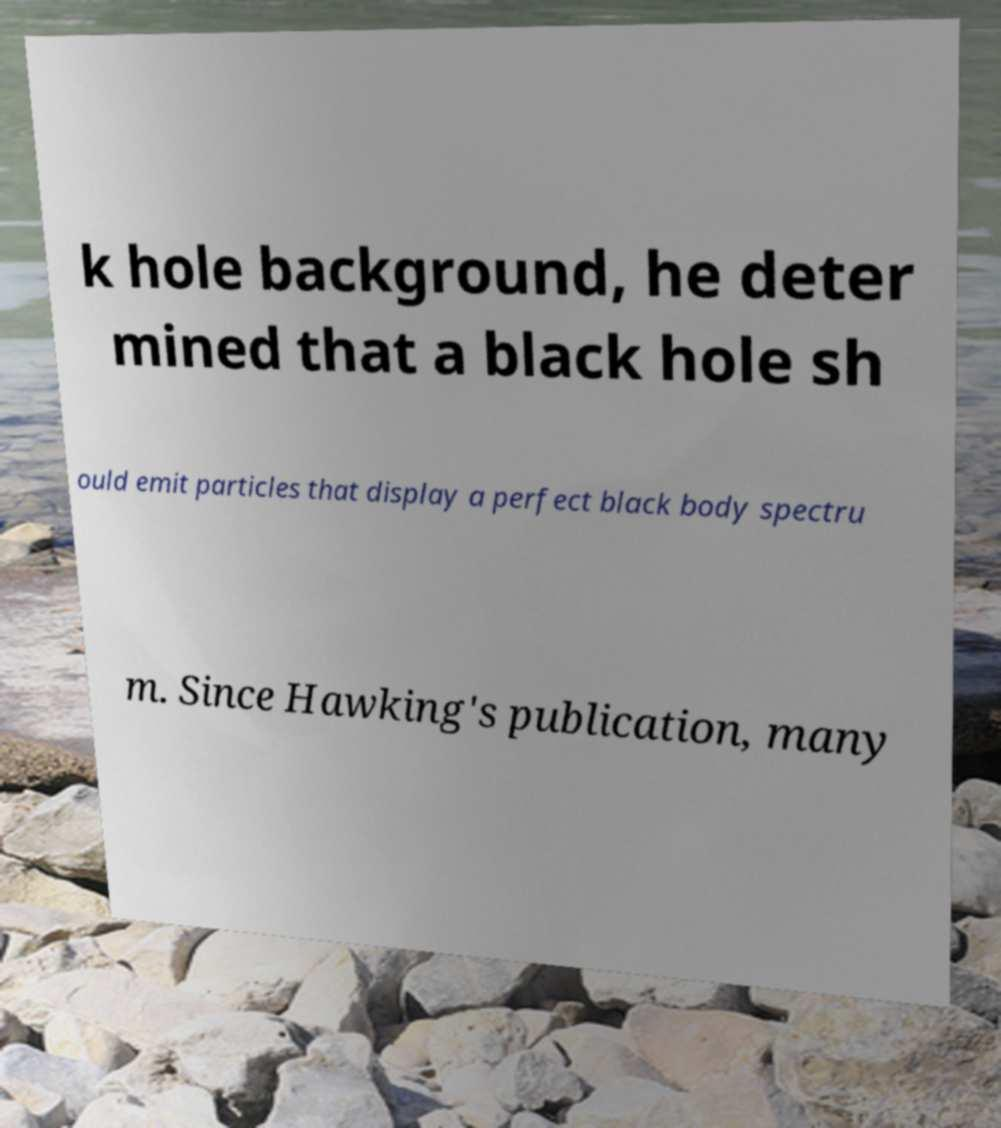I need the written content from this picture converted into text. Can you do that? k hole background, he deter mined that a black hole sh ould emit particles that display a perfect black body spectru m. Since Hawking's publication, many 